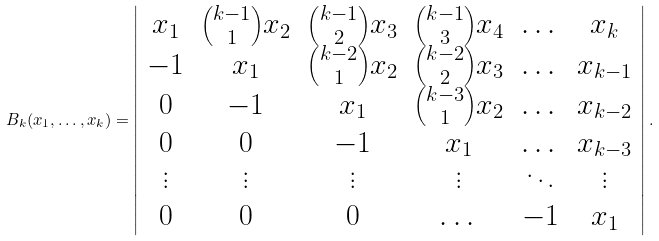<formula> <loc_0><loc_0><loc_500><loc_500>B _ { k } ( x _ { 1 } , \dots , x _ { k } ) = \left | \begin{array} { c c c c c c } x _ { 1 } & { k - 1 \choose 1 } x _ { 2 } & { k - 1 \choose 2 } x _ { 3 } & { k - 1 \choose 3 } x _ { 4 } & \dots & x _ { k } \\ - 1 & x _ { 1 } & { k - 2 \choose 1 } x _ { 2 } & { k - 2 \choose 2 } x _ { 3 } & \dots & x _ { k - 1 } \\ 0 & - 1 & x _ { 1 } & { k - 3 \choose 1 } x _ { 2 } & \dots & x _ { k - 2 } \\ 0 & 0 & - 1 & x _ { 1 } & \dots & x _ { k - 3 } \\ \vdots & \vdots & \vdots & \vdots & \ddots & \vdots \\ 0 & 0 & 0 & \dots & - 1 & x _ { 1 } \end{array} \right | .</formula> 